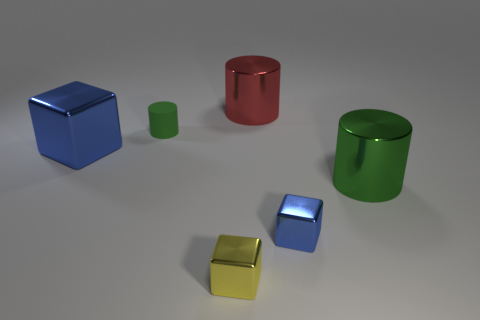Add 1 blocks. How many objects exist? 7 Add 3 brown matte balls. How many brown matte balls exist? 3 Subtract 0 brown blocks. How many objects are left? 6 Subtract all red cylinders. Subtract all blue things. How many objects are left? 3 Add 5 yellow metallic objects. How many yellow metallic objects are left? 6 